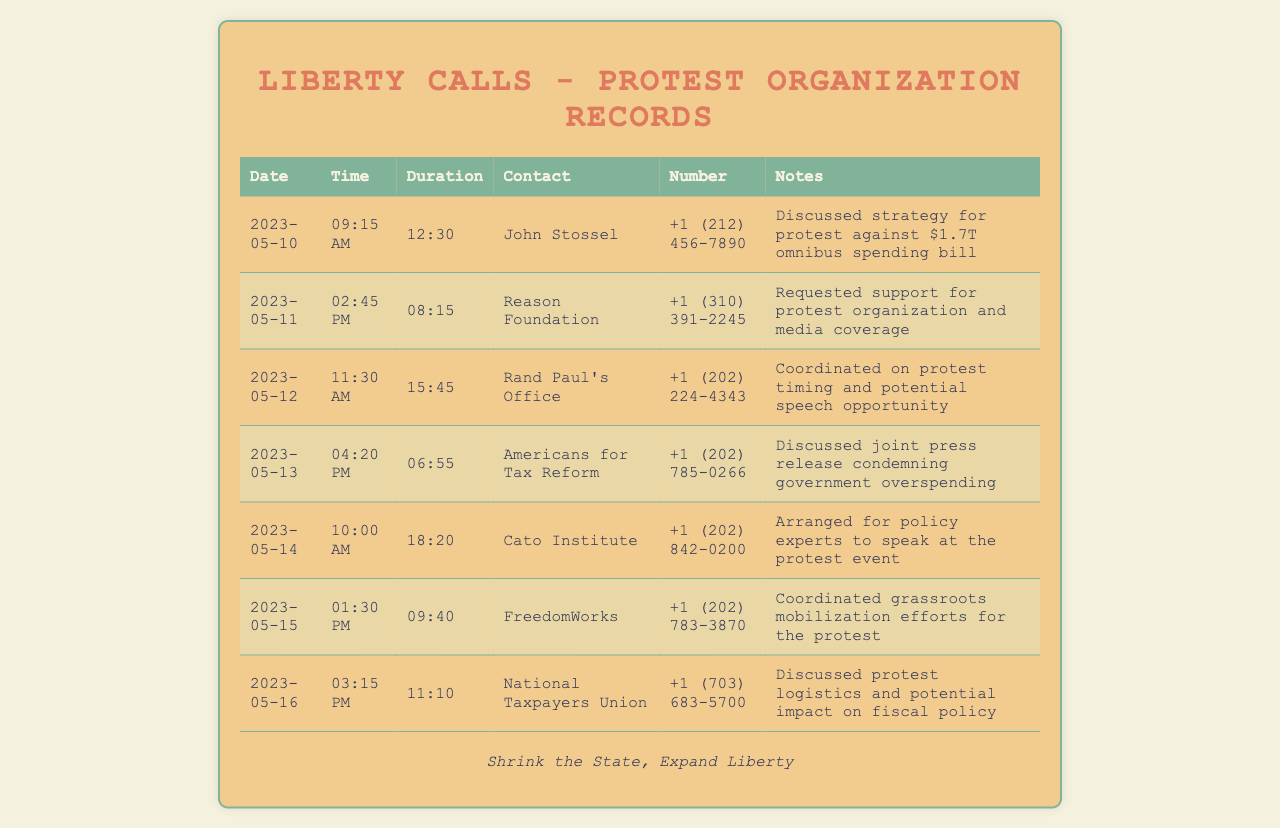what date was the call with John Stossel? The call with John Stossel took place on the date listed in the document, which is May 10, 2023.
Answer: 2023-05-10 how long did the call with Reason Foundation last? The duration of the call with Reason Foundation is specified in the document as 08:15.
Answer: 08:15 who was contacted on May 12, 2023? The contact listed for May 12, 2023, is Rand Paul's Office.
Answer: Rand Paul's Office how many calls were made to discuss logistics? The document shows that two contacts were made regarding logistics: National Taxpayers Union and FreedomWorks.
Answer: 2 what was the main focus of the call with Americans for Tax Reform? The notes indicate that the focus was to discuss a joint press release condemning government overspending.
Answer: joint press release condemning government overspending which organization was involved in grassroots mobilization efforts? The call with FreedomWorks concentrated on grassroots mobilization efforts for the protest.
Answer: FreedomWorks when was the longest call made, and what was its duration? The longest call occurred on May 14, 2023, lasting for 18:20.
Answer: 18:20 how many different organizations were contacted over the week? The document lists calls to six different organizations throughout the week.
Answer: 6 